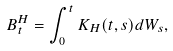<formula> <loc_0><loc_0><loc_500><loc_500>B _ { t } ^ { H } = \int _ { 0 } ^ { t } K _ { H } ( t , s ) d W _ { s } ,</formula> 